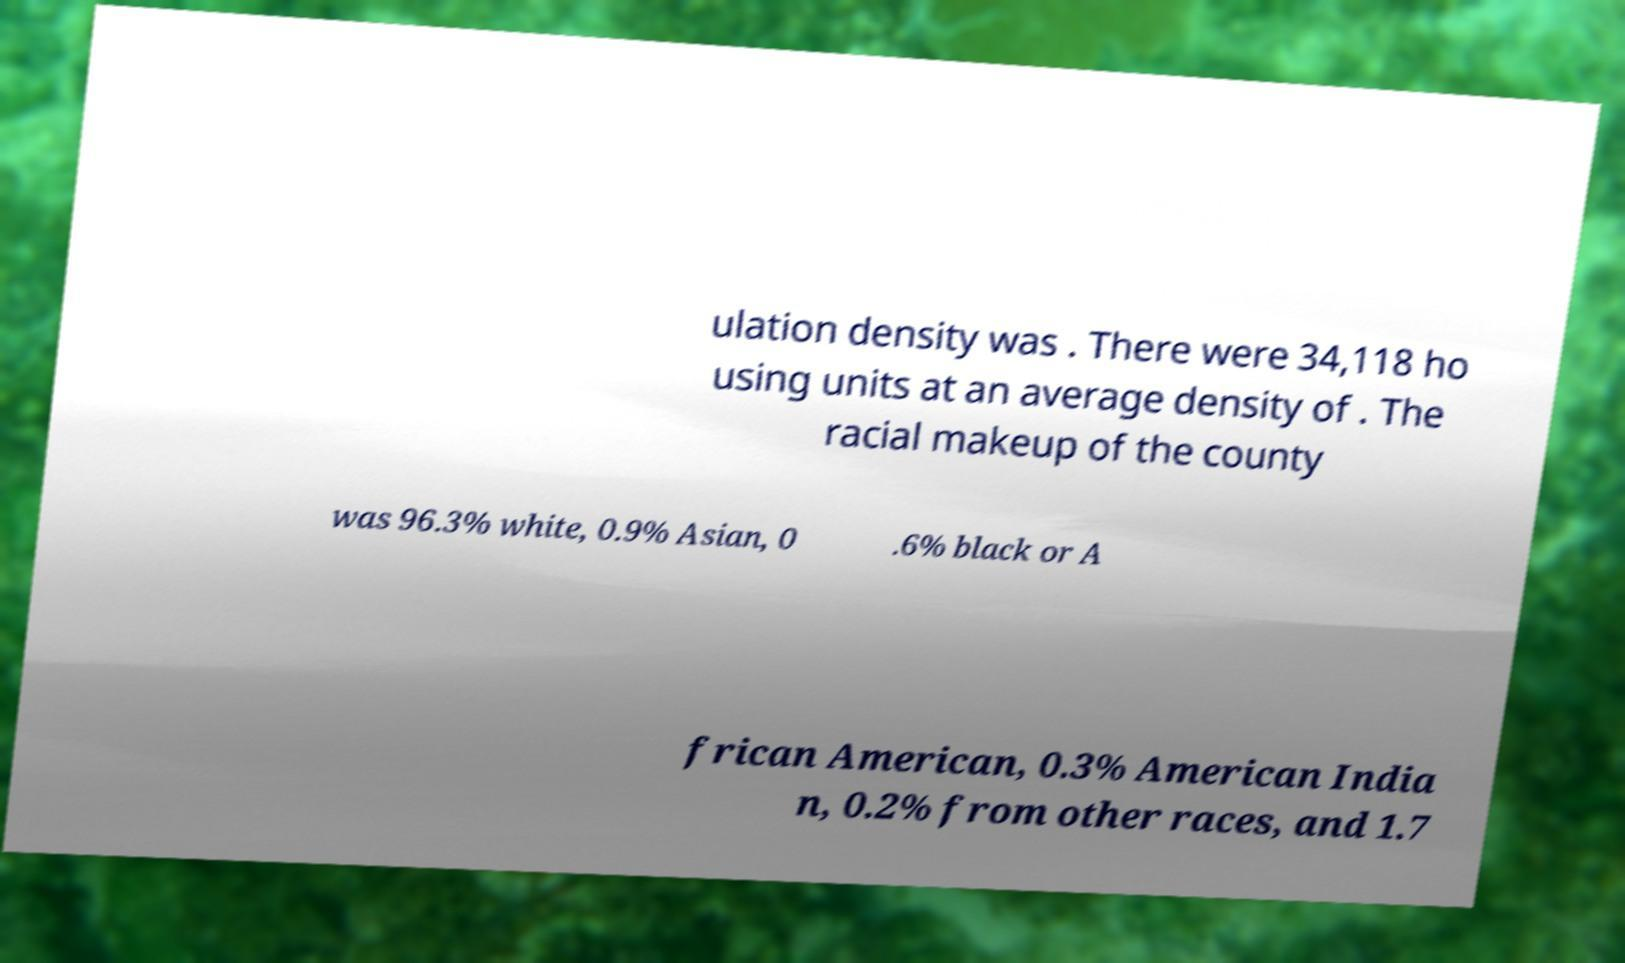Can you read and provide the text displayed in the image?This photo seems to have some interesting text. Can you extract and type it out for me? ulation density was . There were 34,118 ho using units at an average density of . The racial makeup of the county was 96.3% white, 0.9% Asian, 0 .6% black or A frican American, 0.3% American India n, 0.2% from other races, and 1.7 